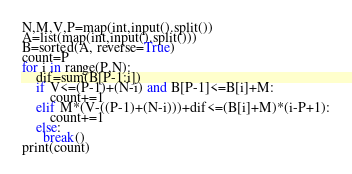Convert code to text. <code><loc_0><loc_0><loc_500><loc_500><_Python_>N,M,V,P=map(int,input().split())
A=list(map(int,input().split()))
B=sorted(A, reverse=True)
count=P
for i in range(P,N):
    dif=sum(B[P-1:i])
    if V<=(P-1)+(N-i) and B[P-1]<=B[i]+M:
        count+=1
    elif M*(V-((P-1)+(N-i)))+dif<=(B[i]+M)*(i-P+1):
        count+=1
    else:
      break()
print(count)</code> 